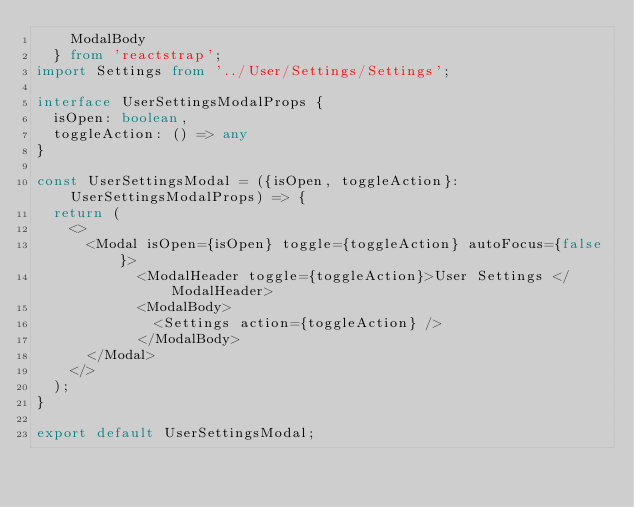<code> <loc_0><loc_0><loc_500><loc_500><_TypeScript_>    ModalBody
  } from 'reactstrap';
import Settings from '../User/Settings/Settings';

interface UserSettingsModalProps {
  isOpen: boolean,
  toggleAction: () => any
}

const UserSettingsModal = ({isOpen, toggleAction}: UserSettingsModalProps) => {
  return (
    <>
      <Modal isOpen={isOpen} toggle={toggleAction} autoFocus={false}>
            <ModalHeader toggle={toggleAction}>User Settings </ModalHeader>
            <ModalBody>
              <Settings action={toggleAction} />
            </ModalBody>
      </Modal>
    </>
  );
}

export default UserSettingsModal;


</code> 